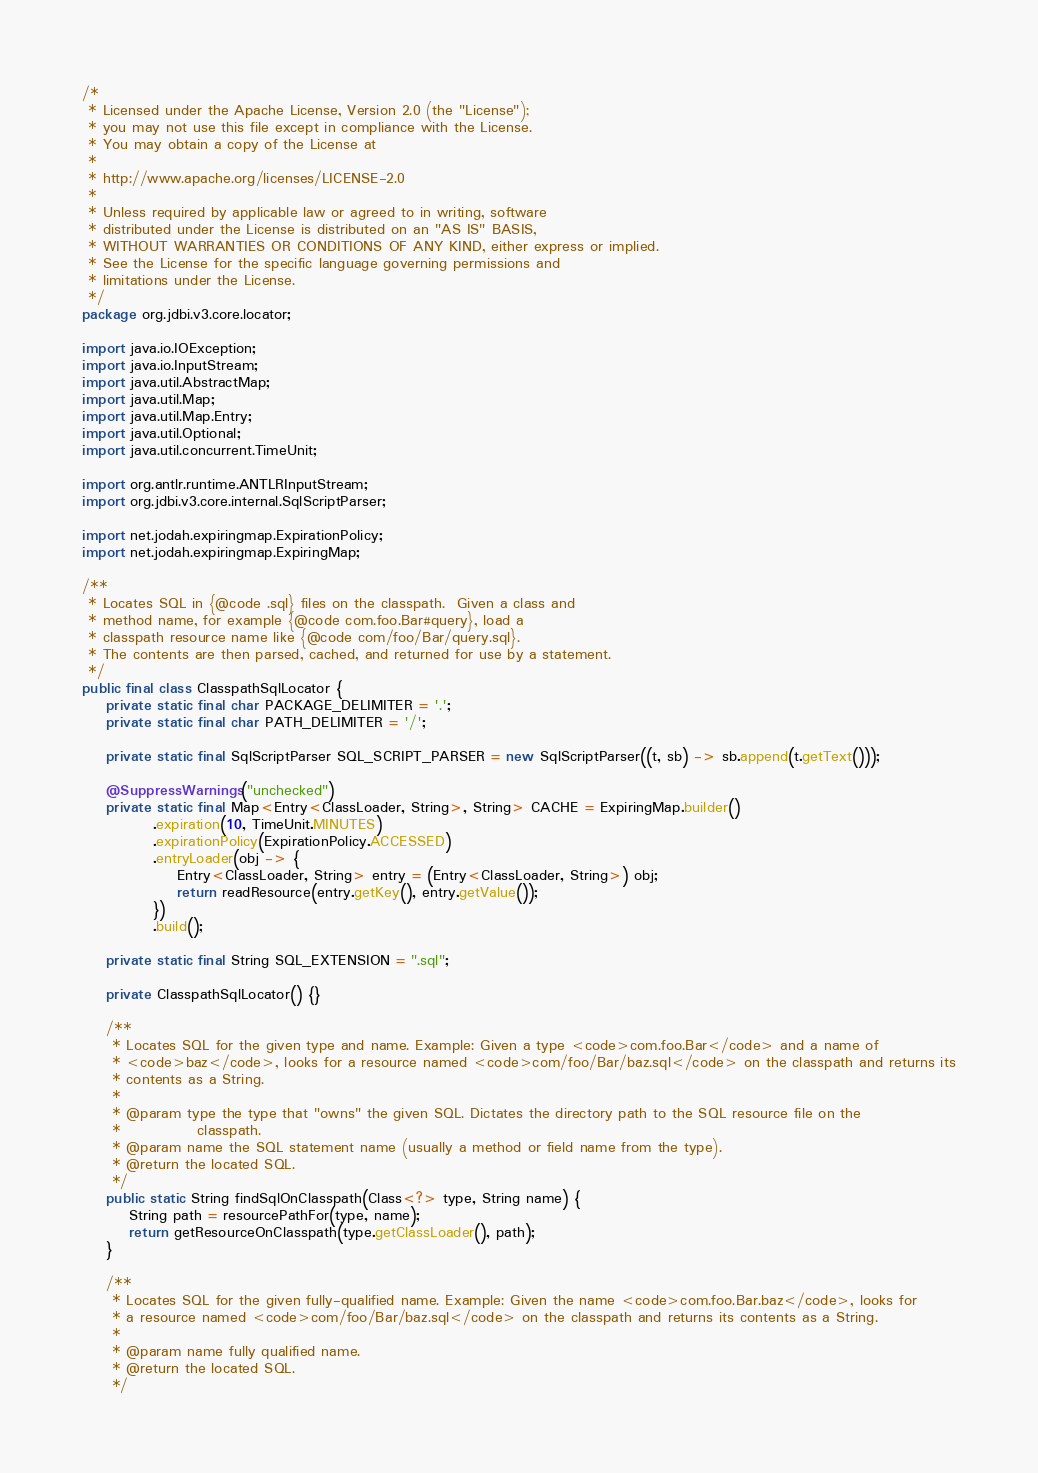Convert code to text. <code><loc_0><loc_0><loc_500><loc_500><_Java_>/*
 * Licensed under the Apache License, Version 2.0 (the "License");
 * you may not use this file except in compliance with the License.
 * You may obtain a copy of the License at
 *
 * http://www.apache.org/licenses/LICENSE-2.0
 *
 * Unless required by applicable law or agreed to in writing, software
 * distributed under the License is distributed on an "AS IS" BASIS,
 * WITHOUT WARRANTIES OR CONDITIONS OF ANY KIND, either express or implied.
 * See the License for the specific language governing permissions and
 * limitations under the License.
 */
package org.jdbi.v3.core.locator;

import java.io.IOException;
import java.io.InputStream;
import java.util.AbstractMap;
import java.util.Map;
import java.util.Map.Entry;
import java.util.Optional;
import java.util.concurrent.TimeUnit;

import org.antlr.runtime.ANTLRInputStream;
import org.jdbi.v3.core.internal.SqlScriptParser;

import net.jodah.expiringmap.ExpirationPolicy;
import net.jodah.expiringmap.ExpiringMap;

/**
 * Locates SQL in {@code .sql} files on the classpath.  Given a class and
 * method name, for example {@code com.foo.Bar#query}, load a
 * classpath resource name like {@code com/foo/Bar/query.sql}.
 * The contents are then parsed, cached, and returned for use by a statement.
 */
public final class ClasspathSqlLocator {
    private static final char PACKAGE_DELIMITER = '.';
    private static final char PATH_DELIMITER = '/';

    private static final SqlScriptParser SQL_SCRIPT_PARSER = new SqlScriptParser((t, sb) -> sb.append(t.getText()));

    @SuppressWarnings("unchecked")
    private static final Map<Entry<ClassLoader, String>, String> CACHE = ExpiringMap.builder()
            .expiration(10, TimeUnit.MINUTES)
            .expirationPolicy(ExpirationPolicy.ACCESSED)
            .entryLoader(obj -> {
                Entry<ClassLoader, String> entry = (Entry<ClassLoader, String>) obj;
                return readResource(entry.getKey(), entry.getValue());
            })
            .build();

    private static final String SQL_EXTENSION = ".sql";

    private ClasspathSqlLocator() {}

    /**
     * Locates SQL for the given type and name. Example: Given a type <code>com.foo.Bar</code> and a name of
     * <code>baz</code>, looks for a resource named <code>com/foo/Bar/baz.sql</code> on the classpath and returns its
     * contents as a String.
     *
     * @param type the type that "owns" the given SQL. Dictates the directory path to the SQL resource file on the
     *             classpath.
     * @param name the SQL statement name (usually a method or field name from the type).
     * @return the located SQL.
     */
    public static String findSqlOnClasspath(Class<?> type, String name) {
        String path = resourcePathFor(type, name);
        return getResourceOnClasspath(type.getClassLoader(), path);
    }

    /**
     * Locates SQL for the given fully-qualified name. Example: Given the name <code>com.foo.Bar.baz</code>, looks for
     * a resource named <code>com/foo/Bar/baz.sql</code> on the classpath and returns its contents as a String.
     *
     * @param name fully qualified name.
     * @return the located SQL.
     */</code> 